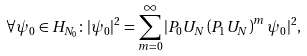<formula> <loc_0><loc_0><loc_500><loc_500>\forall \psi _ { 0 } \in H _ { N _ { 0 } } \colon | \psi _ { 0 } | ^ { 2 } = \sum _ { m = 0 } ^ { \infty } | P _ { 0 } U _ { N } \left ( P _ { 1 } U _ { N } \right ) ^ { m } \psi _ { 0 } | ^ { 2 } ,</formula> 